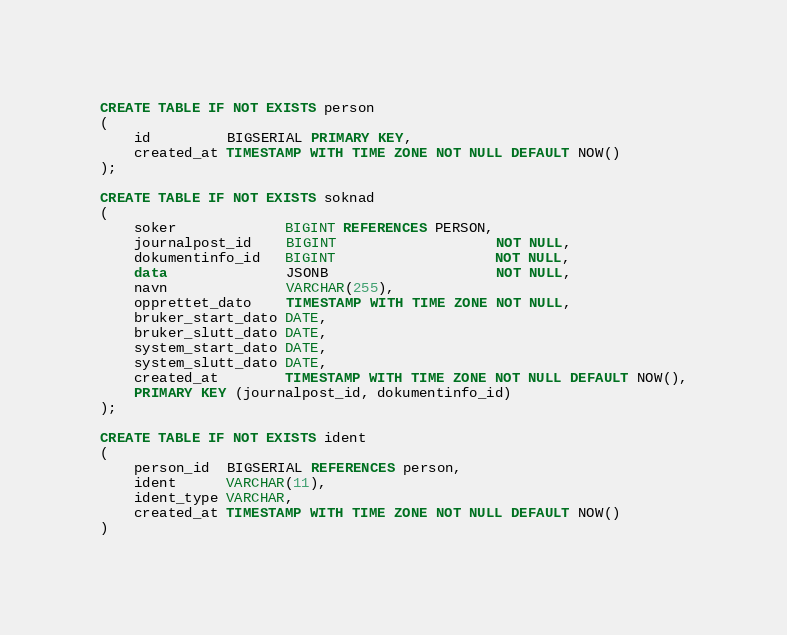Convert code to text. <code><loc_0><loc_0><loc_500><loc_500><_SQL_>CREATE TABLE IF NOT EXISTS person
(
    id         BIGSERIAL PRIMARY KEY,
    created_at TIMESTAMP WITH TIME ZONE NOT NULL DEFAULT NOW()
);

CREATE TABLE IF NOT EXISTS soknad
(
    soker             BIGINT REFERENCES PERSON,
    journalpost_id    BIGINT                   NOT NULL,
    dokumentinfo_id   BIGINT                   NOT NULL,
    data              JSONB                    NOT NULL,
    navn              VARCHAR(255),
    opprettet_dato    TIMESTAMP WITH TIME ZONE NOT NULL,
    bruker_start_dato DATE,
    bruker_slutt_dato DATE,
    system_start_dato DATE,
    system_slutt_dato DATE,
    created_at        TIMESTAMP WITH TIME ZONE NOT NULL DEFAULT NOW(),
    PRIMARY KEY (journalpost_id, dokumentinfo_id)
);

CREATE TABLE IF NOT EXISTS ident
(
    person_id  BIGSERIAL REFERENCES person,
    ident      VARCHAR(11),
    ident_type VARCHAR,
    created_at TIMESTAMP WITH TIME ZONE NOT NULL DEFAULT NOW()
)</code> 